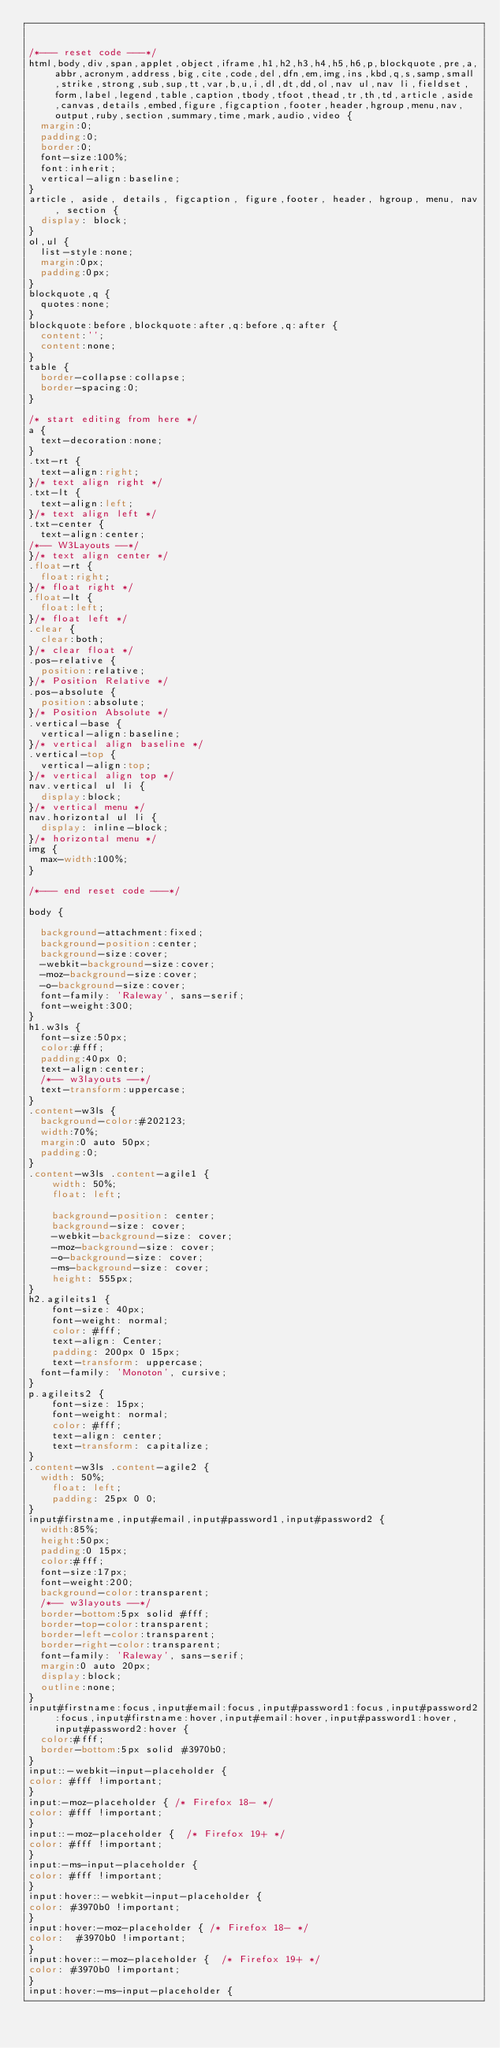Convert code to text. <code><loc_0><loc_0><loc_500><loc_500><_CSS_>

/*--- reset code ---*/
html,body,div,span,applet,object,iframe,h1,h2,h3,h4,h5,h6,p,blockquote,pre,a,abbr,acronym,address,big,cite,code,del,dfn,em,img,ins,kbd,q,s,samp,small,strike,strong,sub,sup,tt,var,b,u,i,dl,dt,dd,ol,nav ul,nav li,fieldset,form,label,legend,table,caption,tbody,tfoot,thead,tr,th,td,article,aside,canvas,details,embed,figure,figcaption,footer,header,hgroup,menu,nav,output,ruby,section,summary,time,mark,audio,video {
	margin:0;
	padding:0;
	border:0;
	font-size:100%;
	font:inherit;
	vertical-align:baseline;
}
article, aside, details, figcaption, figure,footer, header, hgroup, menu, nav, section {
	display: block;
}
ol,ul {
	list-style:none;
	margin:0px;
	padding:0px;
}
blockquote,q {
	quotes:none;
}
blockquote:before,blockquote:after,q:before,q:after {
	content:'';
	content:none;
}
table {
	border-collapse:collapse;
	border-spacing:0;
}

/* start editing from here */
a {
	text-decoration:none;
}
.txt-rt {
	text-align:right;
}/* text align right */
.txt-lt {
	text-align:left;
}/* text align left */
.txt-center {
	text-align:center;
/*-- W3Layouts --*/
}/* text align center */
.float-rt {
	float:right;
}/* float right */
.float-lt {
	float:left;
}/* float left */
.clear {
	clear:both;
}/* clear float */
.pos-relative {
	position:relative;
}/* Position Relative */
.pos-absolute {
	position:absolute;
}/* Position Absolute */
.vertical-base {
	vertical-align:baseline;
}/* vertical align baseline */
.vertical-top {
	vertical-align:top;
}/* vertical align top */
nav.vertical ul li {
	display:block;
}/* vertical menu */
nav.horizontal ul li {
	display: inline-block;
}/* horizontal menu */
img {
	max-width:100%;
}

/*--- end reset code ---*/

body {

	background-attachment:fixed;
	background-position:center;
	background-size:cover;
	-webkit-background-size:cover;
	-moz-background-size:cover;
	-o-background-size:cover;
	font-family: 'Raleway', sans-serif;
	font-weight:300;
}
h1.w3ls {
	font-size:50px;
	color:#fff;
	padding:40px 0;
	text-align:center;
	/*-- w3layouts --*/
	text-transform:uppercase;
}
.content-w3ls {
	background-color:#202123;
	width:70%;
	margin:0 auto 50px;
	padding:0;
}
.content-w3ls .content-agile1 {
    width: 50%;
    float: left;

    background-position: center;
    background-size: cover;
    -webkit-background-size: cover;
    -moz-background-size: cover;
    -o-background-size: cover;
    -ms-background-size: cover;
    height: 555px;
}
h2.agileits1 {
    font-size: 40px;
    font-weight: normal;
    color: #fff;
    text-align: Center;
    padding: 200px 0 15px;
    text-transform: uppercase;
	font-family: 'Monoton', cursive;
}
p.agileits2 {
    font-size: 15px;
    font-weight: normal;
    color: #fff;
    text-align: center;
    text-transform: capitalize;
}
.content-w3ls .content-agile2 {
	width: 50%;
    float: left;
    padding: 25px 0 0;
}
input#firstname,input#email,input#password1,input#password2 {
	width:85%;
	height:50px;
	padding:0 15px;
	color:#fff;
	font-size:17px;
	font-weight:200;
	background-color:transparent;
	/*-- w3layouts --*/
	border-bottom:5px solid #fff;
	border-top-color:transparent;
	border-left-color:transparent;
	border-right-color:transparent;
	font-family: 'Raleway', sans-serif;
	margin:0 auto 20px;
	display:block;
	outline:none;
}
input#firstname:focus,input#email:focus,input#password1:focus,input#password2:focus,input#firstname:hover,input#email:hover,input#password1:hover,input#password2:hover {
	color:#fff;
	border-bottom:5px solid #3970b0;
}
input::-webkit-input-placeholder {
color: #fff !important;
}
input:-moz-placeholder { /* Firefox 18- */
color: #fff !important;
}
input::-moz-placeholder {  /* Firefox 19+ */
color: #fff !important;
}
input:-ms-input-placeholder {
color: #fff !important;
}
input:hover::-webkit-input-placeholder {
color: #3970b0 !important;
}
input:hover:-moz-placeholder { /* Firefox 18- */
color:	#3970b0 !important;
}
input:hover::-moz-placeholder {  /* Firefox 19+ */
color: #3970b0 !important;
}
input:hover:-ms-input-placeholder {</code> 